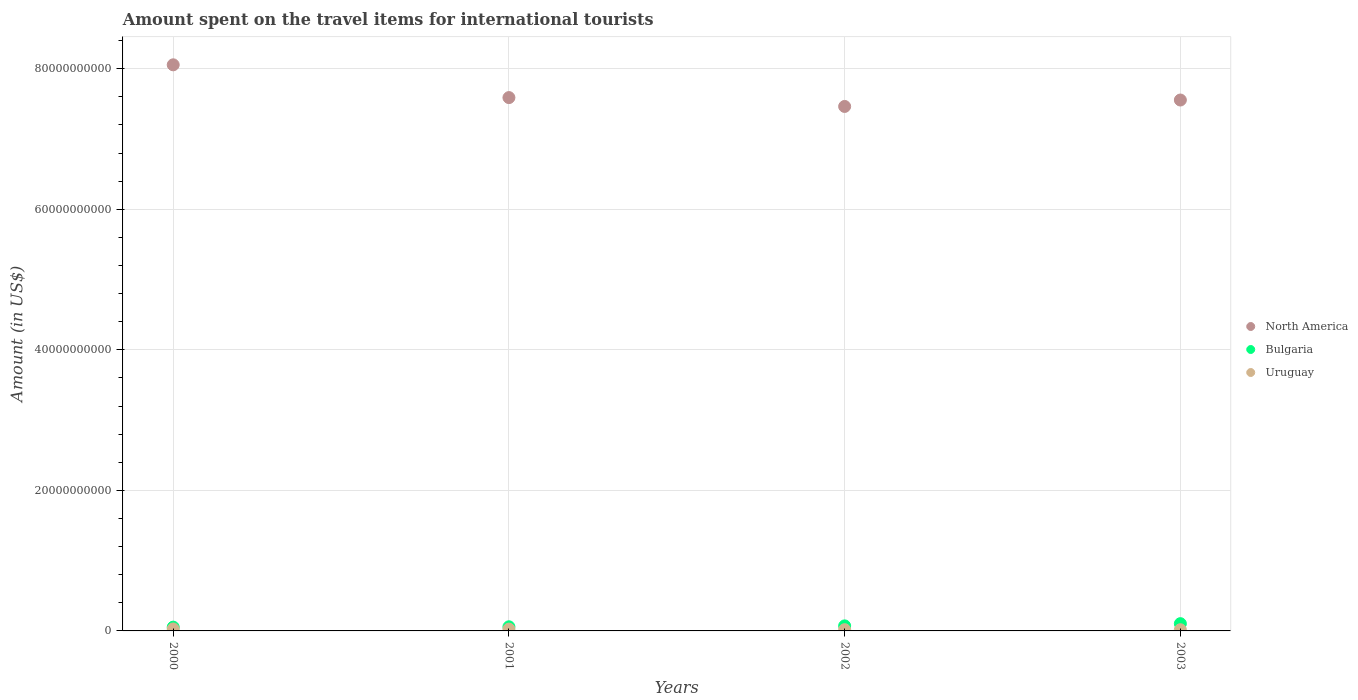What is the amount spent on the travel items for international tourists in Bulgaria in 2000?
Make the answer very short. 5.38e+08. Across all years, what is the maximum amount spent on the travel items for international tourists in North America?
Your answer should be very brief. 8.06e+1. Across all years, what is the minimum amount spent on the travel items for international tourists in Bulgaria?
Provide a succinct answer. 5.38e+08. In which year was the amount spent on the travel items for international tourists in Bulgaria maximum?
Offer a terse response. 2003. What is the total amount spent on the travel items for international tourists in Uruguay in the graph?
Make the answer very short. 8.85e+08. What is the difference between the amount spent on the travel items for international tourists in Bulgaria in 2001 and that in 2002?
Your response must be concise. -1.28e+08. What is the difference between the amount spent on the travel items for international tourists in Bulgaria in 2002 and the amount spent on the travel items for international tourists in Uruguay in 2001?
Provide a succinct answer. 4.60e+08. What is the average amount spent on the travel items for international tourists in Bulgaria per year?
Your answer should be compact. 7.19e+08. In the year 2003, what is the difference between the amount spent on the travel items for international tourists in Uruguay and amount spent on the travel items for international tourists in North America?
Your answer should be very brief. -7.54e+1. What is the ratio of the amount spent on the travel items for international tourists in North America in 2000 to that in 2003?
Offer a terse response. 1.07. Is the amount spent on the travel items for international tourists in Bulgaria in 2001 less than that in 2002?
Your answer should be compact. Yes. What is the difference between the highest and the second highest amount spent on the travel items for international tourists in Uruguay?
Your answer should be very brief. 2.40e+07. What is the difference between the highest and the lowest amount spent on the travel items for international tourists in North America?
Make the answer very short. 5.92e+09. In how many years, is the amount spent on the travel items for international tourists in North America greater than the average amount spent on the travel items for international tourists in North America taken over all years?
Your response must be concise. 1. Does the amount spent on the travel items for international tourists in Uruguay monotonically increase over the years?
Your answer should be very brief. No. Is the amount spent on the travel items for international tourists in Bulgaria strictly greater than the amount spent on the travel items for international tourists in North America over the years?
Your answer should be compact. No. How many dotlines are there?
Ensure brevity in your answer.  3. How many years are there in the graph?
Provide a succinct answer. 4. What is the difference between two consecutive major ticks on the Y-axis?
Your answer should be very brief. 2.00e+1. Are the values on the major ticks of Y-axis written in scientific E-notation?
Give a very brief answer. No. Does the graph contain grids?
Your answer should be very brief. Yes. How many legend labels are there?
Offer a very short reply. 3. How are the legend labels stacked?
Offer a very short reply. Vertical. What is the title of the graph?
Your answer should be very brief. Amount spent on the travel items for international tourists. What is the Amount (in US$) of North America in 2000?
Your response must be concise. 8.06e+1. What is the Amount (in US$) of Bulgaria in 2000?
Your answer should be very brief. 5.38e+08. What is the Amount (in US$) in Uruguay in 2000?
Provide a short and direct response. 2.81e+08. What is the Amount (in US$) in North America in 2001?
Provide a short and direct response. 7.59e+1. What is the Amount (in US$) of Bulgaria in 2001?
Offer a very short reply. 5.89e+08. What is the Amount (in US$) of Uruguay in 2001?
Provide a short and direct response. 2.57e+08. What is the Amount (in US$) in North America in 2002?
Offer a terse response. 7.46e+1. What is the Amount (in US$) in Bulgaria in 2002?
Keep it short and to the point. 7.17e+08. What is the Amount (in US$) of Uruguay in 2002?
Your response must be concise. 1.78e+08. What is the Amount (in US$) of North America in 2003?
Your response must be concise. 7.56e+1. What is the Amount (in US$) of Bulgaria in 2003?
Keep it short and to the point. 1.03e+09. What is the Amount (in US$) of Uruguay in 2003?
Your response must be concise. 1.69e+08. Across all years, what is the maximum Amount (in US$) of North America?
Your answer should be compact. 8.06e+1. Across all years, what is the maximum Amount (in US$) in Bulgaria?
Provide a succinct answer. 1.03e+09. Across all years, what is the maximum Amount (in US$) in Uruguay?
Provide a succinct answer. 2.81e+08. Across all years, what is the minimum Amount (in US$) of North America?
Offer a very short reply. 7.46e+1. Across all years, what is the minimum Amount (in US$) in Bulgaria?
Keep it short and to the point. 5.38e+08. Across all years, what is the minimum Amount (in US$) in Uruguay?
Your answer should be very brief. 1.69e+08. What is the total Amount (in US$) in North America in the graph?
Provide a short and direct response. 3.07e+11. What is the total Amount (in US$) of Bulgaria in the graph?
Keep it short and to the point. 2.88e+09. What is the total Amount (in US$) of Uruguay in the graph?
Provide a short and direct response. 8.85e+08. What is the difference between the Amount (in US$) in North America in 2000 and that in 2001?
Offer a very short reply. 4.66e+09. What is the difference between the Amount (in US$) in Bulgaria in 2000 and that in 2001?
Keep it short and to the point. -5.10e+07. What is the difference between the Amount (in US$) in Uruguay in 2000 and that in 2001?
Your answer should be very brief. 2.40e+07. What is the difference between the Amount (in US$) of North America in 2000 and that in 2002?
Your answer should be very brief. 5.92e+09. What is the difference between the Amount (in US$) in Bulgaria in 2000 and that in 2002?
Provide a short and direct response. -1.79e+08. What is the difference between the Amount (in US$) in Uruguay in 2000 and that in 2002?
Your response must be concise. 1.03e+08. What is the difference between the Amount (in US$) in North America in 2000 and that in 2003?
Your answer should be compact. 5.01e+09. What is the difference between the Amount (in US$) in Bulgaria in 2000 and that in 2003?
Ensure brevity in your answer.  -4.95e+08. What is the difference between the Amount (in US$) of Uruguay in 2000 and that in 2003?
Give a very brief answer. 1.12e+08. What is the difference between the Amount (in US$) of North America in 2001 and that in 2002?
Provide a succinct answer. 1.26e+09. What is the difference between the Amount (in US$) in Bulgaria in 2001 and that in 2002?
Offer a terse response. -1.28e+08. What is the difference between the Amount (in US$) in Uruguay in 2001 and that in 2002?
Make the answer very short. 7.90e+07. What is the difference between the Amount (in US$) of North America in 2001 and that in 2003?
Keep it short and to the point. 3.46e+08. What is the difference between the Amount (in US$) in Bulgaria in 2001 and that in 2003?
Provide a succinct answer. -4.44e+08. What is the difference between the Amount (in US$) in Uruguay in 2001 and that in 2003?
Give a very brief answer. 8.80e+07. What is the difference between the Amount (in US$) in North America in 2002 and that in 2003?
Your response must be concise. -9.15e+08. What is the difference between the Amount (in US$) in Bulgaria in 2002 and that in 2003?
Provide a succinct answer. -3.16e+08. What is the difference between the Amount (in US$) of Uruguay in 2002 and that in 2003?
Offer a terse response. 9.00e+06. What is the difference between the Amount (in US$) of North America in 2000 and the Amount (in US$) of Bulgaria in 2001?
Provide a short and direct response. 8.00e+1. What is the difference between the Amount (in US$) of North America in 2000 and the Amount (in US$) of Uruguay in 2001?
Make the answer very short. 8.03e+1. What is the difference between the Amount (in US$) in Bulgaria in 2000 and the Amount (in US$) in Uruguay in 2001?
Make the answer very short. 2.81e+08. What is the difference between the Amount (in US$) of North America in 2000 and the Amount (in US$) of Bulgaria in 2002?
Your response must be concise. 7.98e+1. What is the difference between the Amount (in US$) of North America in 2000 and the Amount (in US$) of Uruguay in 2002?
Give a very brief answer. 8.04e+1. What is the difference between the Amount (in US$) of Bulgaria in 2000 and the Amount (in US$) of Uruguay in 2002?
Offer a terse response. 3.60e+08. What is the difference between the Amount (in US$) in North America in 2000 and the Amount (in US$) in Bulgaria in 2003?
Make the answer very short. 7.95e+1. What is the difference between the Amount (in US$) in North America in 2000 and the Amount (in US$) in Uruguay in 2003?
Offer a very short reply. 8.04e+1. What is the difference between the Amount (in US$) in Bulgaria in 2000 and the Amount (in US$) in Uruguay in 2003?
Keep it short and to the point. 3.69e+08. What is the difference between the Amount (in US$) in North America in 2001 and the Amount (in US$) in Bulgaria in 2002?
Provide a short and direct response. 7.52e+1. What is the difference between the Amount (in US$) of North America in 2001 and the Amount (in US$) of Uruguay in 2002?
Offer a very short reply. 7.57e+1. What is the difference between the Amount (in US$) in Bulgaria in 2001 and the Amount (in US$) in Uruguay in 2002?
Offer a very short reply. 4.11e+08. What is the difference between the Amount (in US$) in North America in 2001 and the Amount (in US$) in Bulgaria in 2003?
Offer a terse response. 7.49e+1. What is the difference between the Amount (in US$) in North America in 2001 and the Amount (in US$) in Uruguay in 2003?
Your response must be concise. 7.57e+1. What is the difference between the Amount (in US$) in Bulgaria in 2001 and the Amount (in US$) in Uruguay in 2003?
Offer a very short reply. 4.20e+08. What is the difference between the Amount (in US$) in North America in 2002 and the Amount (in US$) in Bulgaria in 2003?
Ensure brevity in your answer.  7.36e+1. What is the difference between the Amount (in US$) in North America in 2002 and the Amount (in US$) in Uruguay in 2003?
Offer a very short reply. 7.45e+1. What is the difference between the Amount (in US$) of Bulgaria in 2002 and the Amount (in US$) of Uruguay in 2003?
Your response must be concise. 5.48e+08. What is the average Amount (in US$) in North America per year?
Your answer should be compact. 7.67e+1. What is the average Amount (in US$) in Bulgaria per year?
Your answer should be compact. 7.19e+08. What is the average Amount (in US$) of Uruguay per year?
Your answer should be compact. 2.21e+08. In the year 2000, what is the difference between the Amount (in US$) of North America and Amount (in US$) of Bulgaria?
Keep it short and to the point. 8.00e+1. In the year 2000, what is the difference between the Amount (in US$) of North America and Amount (in US$) of Uruguay?
Your answer should be very brief. 8.03e+1. In the year 2000, what is the difference between the Amount (in US$) of Bulgaria and Amount (in US$) of Uruguay?
Provide a succinct answer. 2.57e+08. In the year 2001, what is the difference between the Amount (in US$) of North America and Amount (in US$) of Bulgaria?
Make the answer very short. 7.53e+1. In the year 2001, what is the difference between the Amount (in US$) of North America and Amount (in US$) of Uruguay?
Your response must be concise. 7.56e+1. In the year 2001, what is the difference between the Amount (in US$) in Bulgaria and Amount (in US$) in Uruguay?
Your answer should be very brief. 3.32e+08. In the year 2002, what is the difference between the Amount (in US$) of North America and Amount (in US$) of Bulgaria?
Ensure brevity in your answer.  7.39e+1. In the year 2002, what is the difference between the Amount (in US$) of North America and Amount (in US$) of Uruguay?
Make the answer very short. 7.45e+1. In the year 2002, what is the difference between the Amount (in US$) in Bulgaria and Amount (in US$) in Uruguay?
Keep it short and to the point. 5.39e+08. In the year 2003, what is the difference between the Amount (in US$) in North America and Amount (in US$) in Bulgaria?
Provide a short and direct response. 7.45e+1. In the year 2003, what is the difference between the Amount (in US$) of North America and Amount (in US$) of Uruguay?
Ensure brevity in your answer.  7.54e+1. In the year 2003, what is the difference between the Amount (in US$) of Bulgaria and Amount (in US$) of Uruguay?
Provide a succinct answer. 8.64e+08. What is the ratio of the Amount (in US$) in North America in 2000 to that in 2001?
Your response must be concise. 1.06. What is the ratio of the Amount (in US$) of Bulgaria in 2000 to that in 2001?
Your answer should be very brief. 0.91. What is the ratio of the Amount (in US$) in Uruguay in 2000 to that in 2001?
Your response must be concise. 1.09. What is the ratio of the Amount (in US$) of North America in 2000 to that in 2002?
Your answer should be very brief. 1.08. What is the ratio of the Amount (in US$) in Bulgaria in 2000 to that in 2002?
Offer a terse response. 0.75. What is the ratio of the Amount (in US$) of Uruguay in 2000 to that in 2002?
Ensure brevity in your answer.  1.58. What is the ratio of the Amount (in US$) of North America in 2000 to that in 2003?
Offer a very short reply. 1.07. What is the ratio of the Amount (in US$) in Bulgaria in 2000 to that in 2003?
Give a very brief answer. 0.52. What is the ratio of the Amount (in US$) in Uruguay in 2000 to that in 2003?
Keep it short and to the point. 1.66. What is the ratio of the Amount (in US$) of North America in 2001 to that in 2002?
Provide a succinct answer. 1.02. What is the ratio of the Amount (in US$) in Bulgaria in 2001 to that in 2002?
Your answer should be compact. 0.82. What is the ratio of the Amount (in US$) of Uruguay in 2001 to that in 2002?
Make the answer very short. 1.44. What is the ratio of the Amount (in US$) of North America in 2001 to that in 2003?
Offer a very short reply. 1. What is the ratio of the Amount (in US$) of Bulgaria in 2001 to that in 2003?
Provide a succinct answer. 0.57. What is the ratio of the Amount (in US$) in Uruguay in 2001 to that in 2003?
Your response must be concise. 1.52. What is the ratio of the Amount (in US$) of North America in 2002 to that in 2003?
Your answer should be very brief. 0.99. What is the ratio of the Amount (in US$) in Bulgaria in 2002 to that in 2003?
Offer a very short reply. 0.69. What is the ratio of the Amount (in US$) in Uruguay in 2002 to that in 2003?
Your response must be concise. 1.05. What is the difference between the highest and the second highest Amount (in US$) of North America?
Provide a short and direct response. 4.66e+09. What is the difference between the highest and the second highest Amount (in US$) in Bulgaria?
Make the answer very short. 3.16e+08. What is the difference between the highest and the second highest Amount (in US$) in Uruguay?
Provide a succinct answer. 2.40e+07. What is the difference between the highest and the lowest Amount (in US$) of North America?
Make the answer very short. 5.92e+09. What is the difference between the highest and the lowest Amount (in US$) of Bulgaria?
Offer a terse response. 4.95e+08. What is the difference between the highest and the lowest Amount (in US$) in Uruguay?
Offer a terse response. 1.12e+08. 